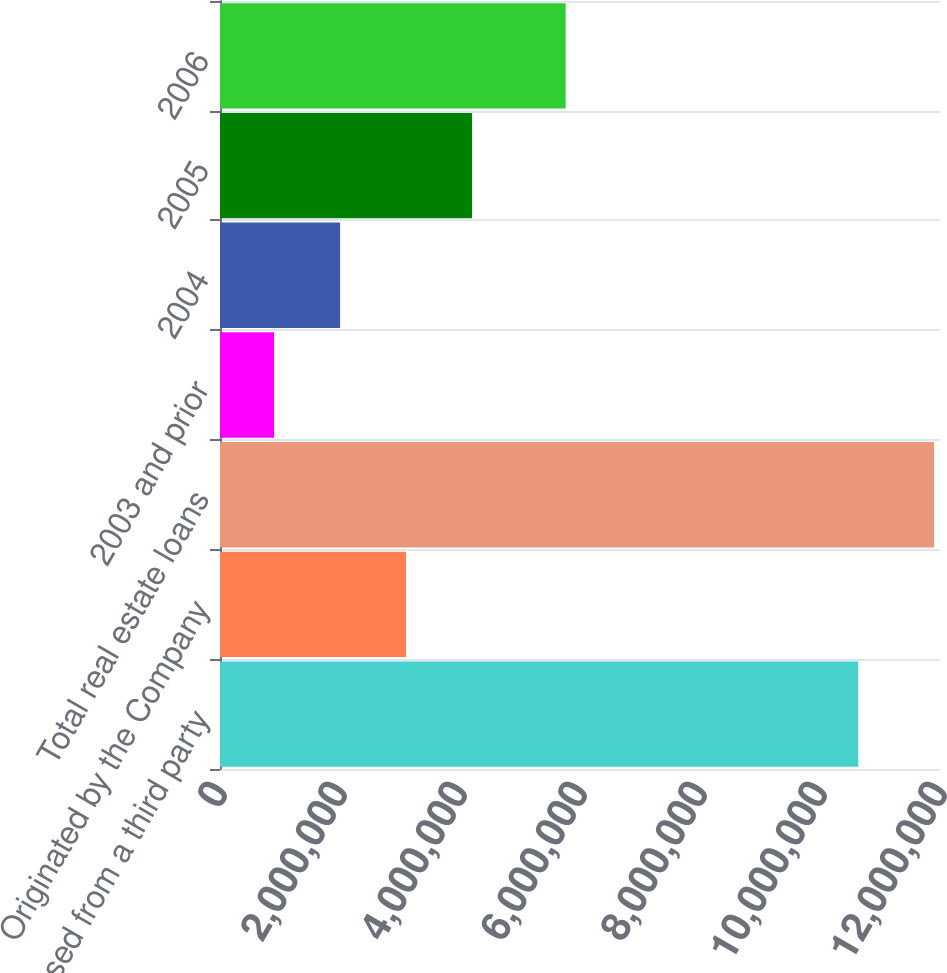Convert chart. <chart><loc_0><loc_0><loc_500><loc_500><bar_chart><fcel>Purchased from a third party<fcel>Originated by the Company<fcel>Total real estate loans<fcel>2003 and prior<fcel>2004<fcel>2005<fcel>2006<nl><fcel>1.0638e+07<fcel>3.10126e+06<fcel>1.19013e+07<fcel>901240<fcel>2.00125e+06<fcel>4.20127e+06<fcel>5.76091e+06<nl></chart> 